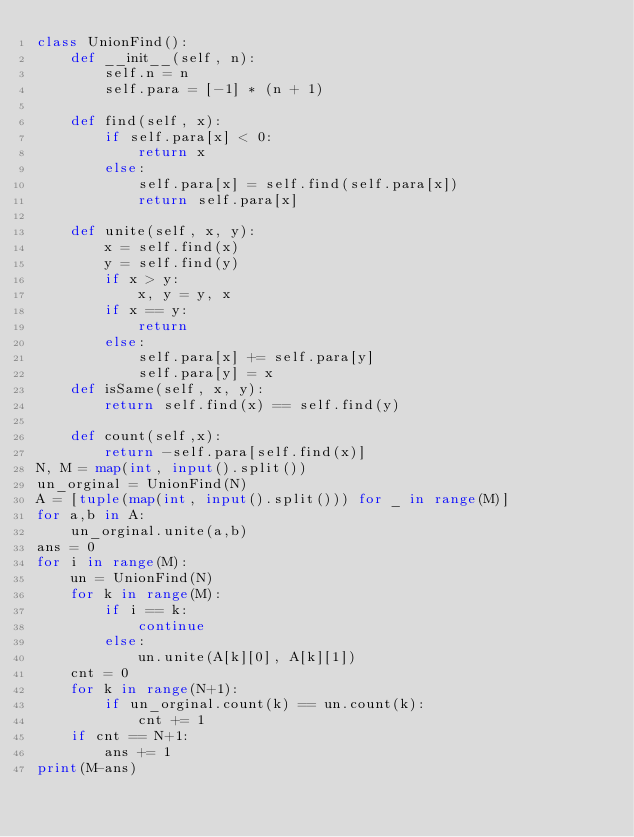Convert code to text. <code><loc_0><loc_0><loc_500><loc_500><_Python_>class UnionFind():
    def __init__(self, n):
        self.n = n
        self.para = [-1] * (n + 1)
    
    def find(self, x):
        if self.para[x] < 0:
            return x
        else:
            self.para[x] = self.find(self.para[x])
            return self.para[x]
    
    def unite(self, x, y):
        x = self.find(x)
        y = self.find(y)
        if x > y:
            x, y = y, x
        if x == y:
            return
        else:
            self.para[x] += self.para[y]
            self.para[y] = x
    def isSame(self, x, y):
        return self.find(x) == self.find(y)
    
    def count(self,x):
        return -self.para[self.find(x)]
N, M = map(int, input().split())
un_orginal = UnionFind(N)
A = [tuple(map(int, input().split())) for _ in range(M)]
for a,b in A:
    un_orginal.unite(a,b)
ans = 0
for i in range(M):
    un = UnionFind(N)
    for k in range(M):
        if i == k:
            continue
        else:
            un.unite(A[k][0], A[k][1])
    cnt = 0
    for k in range(N+1):
        if un_orginal.count(k) == un.count(k):
            cnt += 1
    if cnt == N+1:
        ans += 1
print(M-ans)</code> 